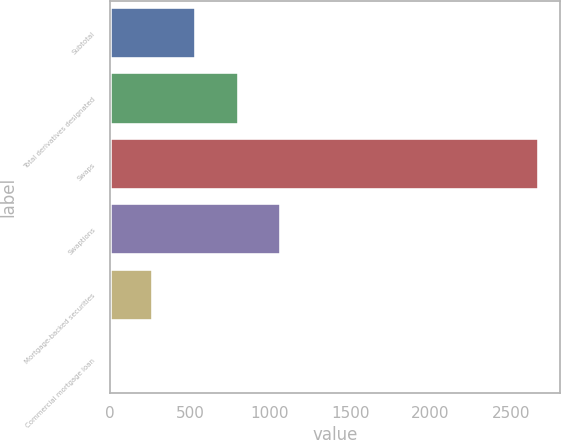<chart> <loc_0><loc_0><loc_500><loc_500><bar_chart><fcel>Subtotal<fcel>Total derivatives designated<fcel>Swaps<fcel>Swaptions<fcel>Mortgage-backed securities<fcel>Commercial mortgage loan<nl><fcel>537<fcel>804<fcel>2673<fcel>1071<fcel>270<fcel>3<nl></chart> 